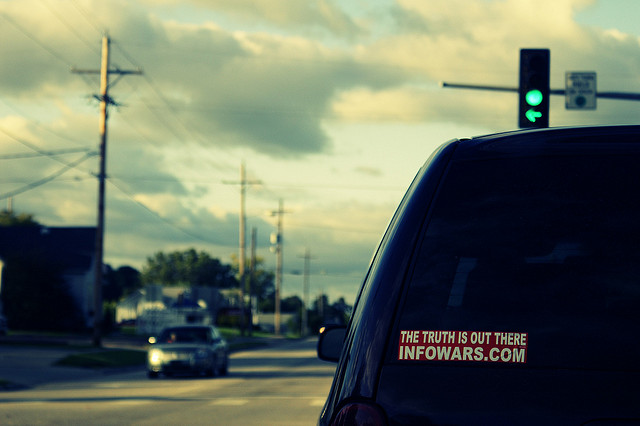Identify the text contained in this image. THE TRUTH IS OUT THERE INFORWARS.COM 